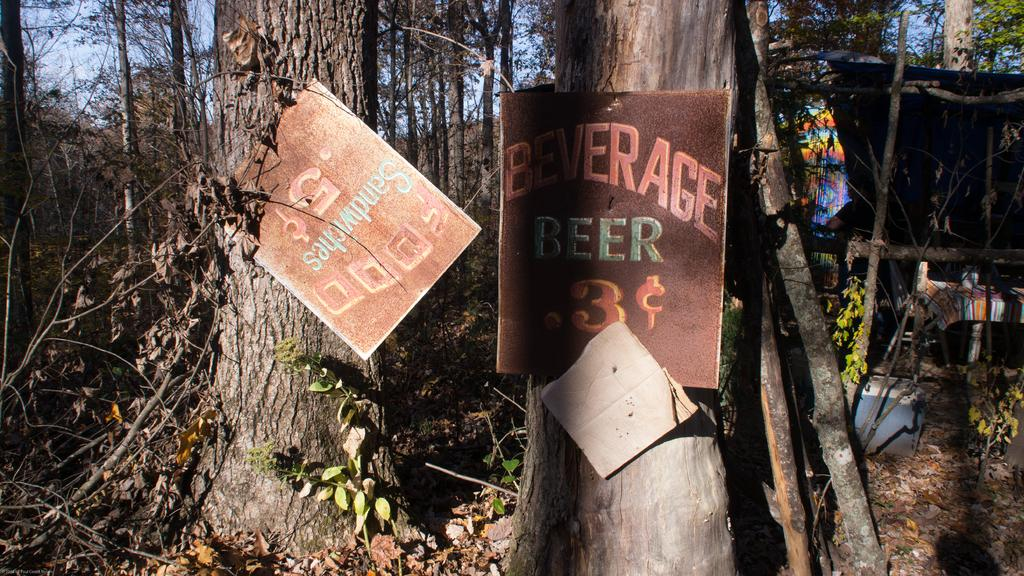What type of vegetation is present in the image? There is a group of trees in the image. What is unusual about the trees in the image? There are boats on the trees. What can be seen on the right side of the image? There are objects on the right side of the image. What is at the bottom of the image? There is grass and dry leaves at the bottom of the image. What type of key is used to unlock the zinc apparatus in the image? There is no key or zinc apparatus present in the image. 